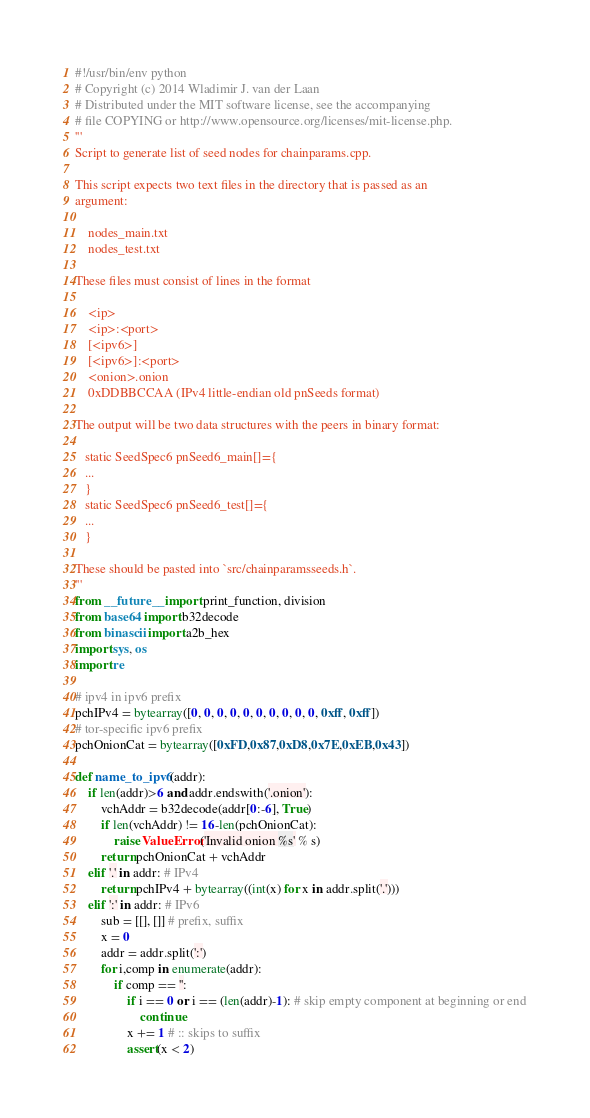<code> <loc_0><loc_0><loc_500><loc_500><_Python_>#!/usr/bin/env python
# Copyright (c) 2014 Wladimir J. van der Laan
# Distributed under the MIT software license, see the accompanying
# file COPYING or http://www.opensource.org/licenses/mit-license.php.
'''
Script to generate list of seed nodes for chainparams.cpp.

This script expects two text files in the directory that is passed as an
argument:

    nodes_main.txt
    nodes_test.txt

These files must consist of lines in the format

    <ip>
    <ip>:<port>
    [<ipv6>]
    [<ipv6>]:<port>
    <onion>.onion
    0xDDBBCCAA (IPv4 little-endian old pnSeeds format)

The output will be two data structures with the peers in binary format:

   static SeedSpec6 pnSeed6_main[]={
   ...
   }
   static SeedSpec6 pnSeed6_test[]={
   ...
   }

These should be pasted into `src/chainparamsseeds.h`.
'''
from __future__ import print_function, division
from base64 import b32decode
from binascii import a2b_hex
import sys, os
import re

# ipv4 in ipv6 prefix
pchIPv4 = bytearray([0, 0, 0, 0, 0, 0, 0, 0, 0, 0, 0xff, 0xff])
# tor-specific ipv6 prefix
pchOnionCat = bytearray([0xFD,0x87,0xD8,0x7E,0xEB,0x43])

def name_to_ipv6(addr):
    if len(addr)>6 and addr.endswith('.onion'):
        vchAddr = b32decode(addr[0:-6], True)
        if len(vchAddr) != 16-len(pchOnionCat):
            raise ValueError('Invalid onion %s' % s)
        return pchOnionCat + vchAddr
    elif '.' in addr: # IPv4
        return pchIPv4 + bytearray((int(x) for x in addr.split('.')))
    elif ':' in addr: # IPv6
        sub = [[], []] # prefix, suffix
        x = 0
        addr = addr.split(':')
        for i,comp in enumerate(addr):
            if comp == '':
                if i == 0 or i == (len(addr)-1): # skip empty component at beginning or end
                    continue
                x += 1 # :: skips to suffix
                assert(x < 2)</code> 